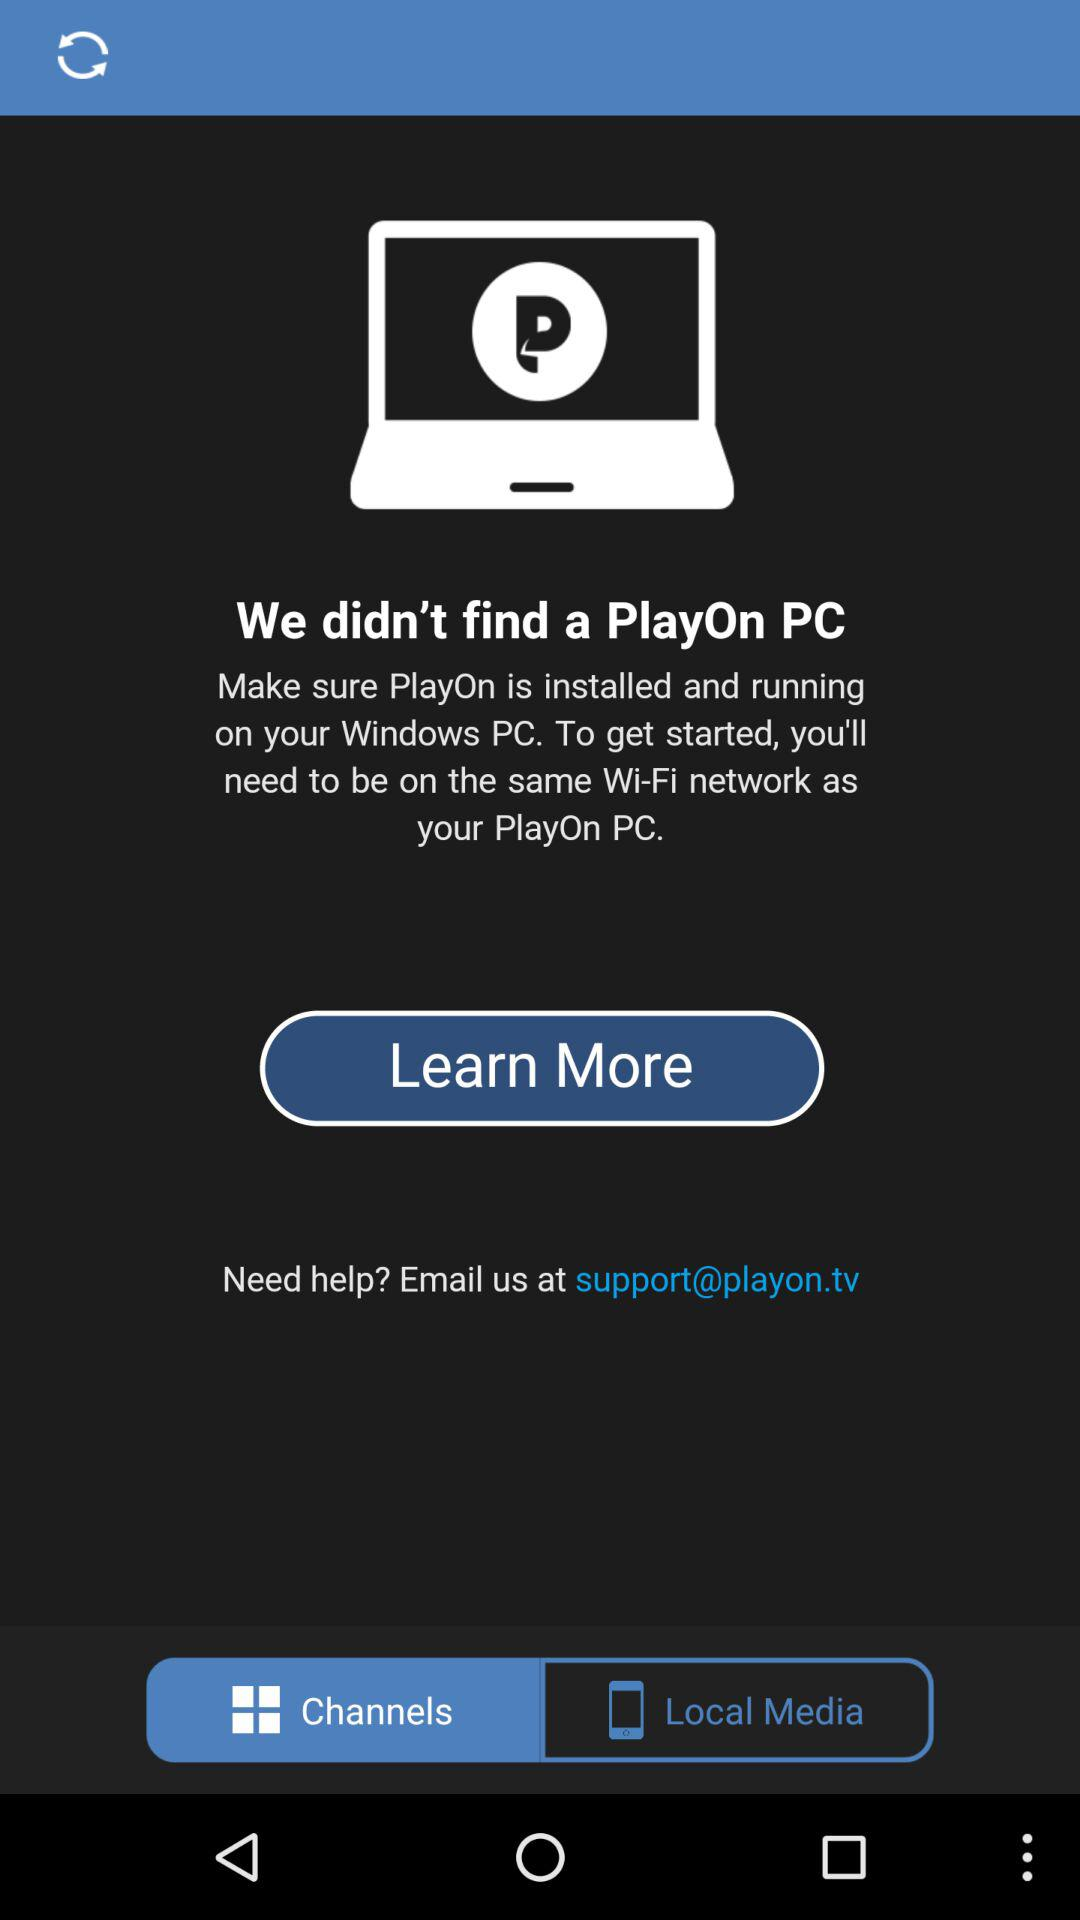What's the application name? The application name is "PlayOn". 